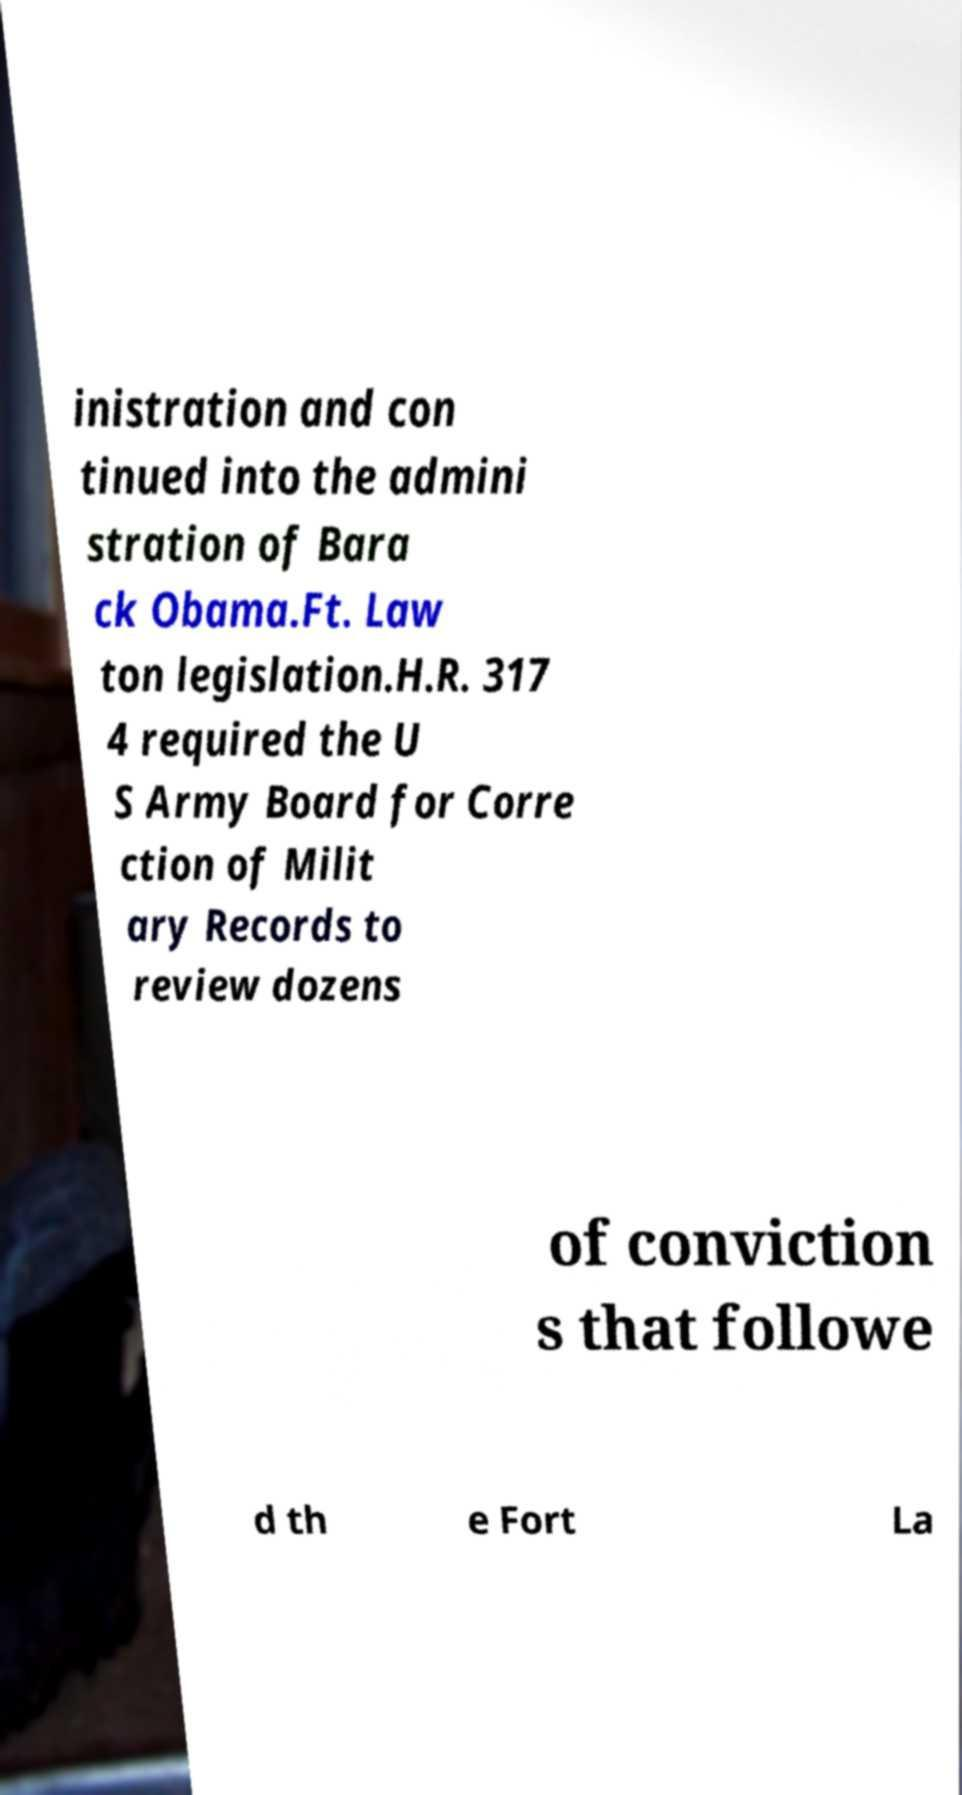Please identify and transcribe the text found in this image. inistration and con tinued into the admini stration of Bara ck Obama.Ft. Law ton legislation.H.R. 317 4 required the U S Army Board for Corre ction of Milit ary Records to review dozens of conviction s that followe d th e Fort La 